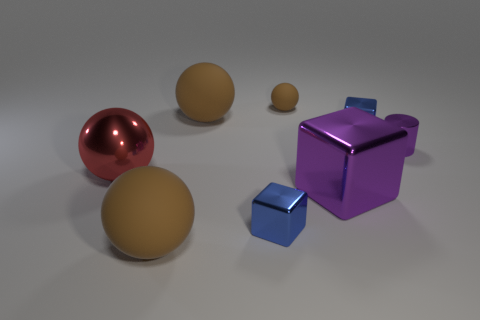Subtract all blue cubes. How many cubes are left? 1 Add 1 big red metal things. How many objects exist? 9 Subtract 0 green cylinders. How many objects are left? 8 Subtract all cubes. How many objects are left? 5 Subtract 2 spheres. How many spheres are left? 2 Subtract all brown blocks. Subtract all green cylinders. How many blocks are left? 3 Subtract all gray cubes. How many blue cylinders are left? 0 Subtract all blocks. Subtract all tiny purple objects. How many objects are left? 4 Add 8 big purple things. How many big purple things are left? 9 Add 2 big matte things. How many big matte things exist? 4 